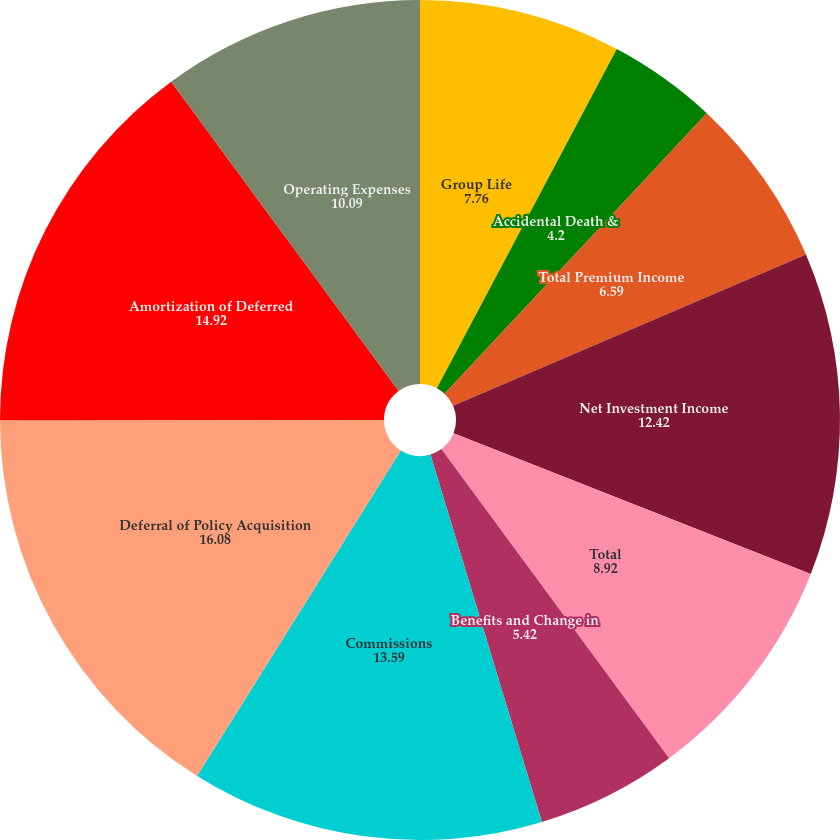Convert chart. <chart><loc_0><loc_0><loc_500><loc_500><pie_chart><fcel>Group Life<fcel>Accidental Death &<fcel>Total Premium Income<fcel>Net Investment Income<fcel>Total<fcel>Benefits and Change in<fcel>Commissions<fcel>Deferral of Policy Acquisition<fcel>Amortization of Deferred<fcel>Operating Expenses<nl><fcel>7.76%<fcel>4.2%<fcel>6.59%<fcel>12.42%<fcel>8.92%<fcel>5.42%<fcel>13.59%<fcel>16.08%<fcel>14.92%<fcel>10.09%<nl></chart> 